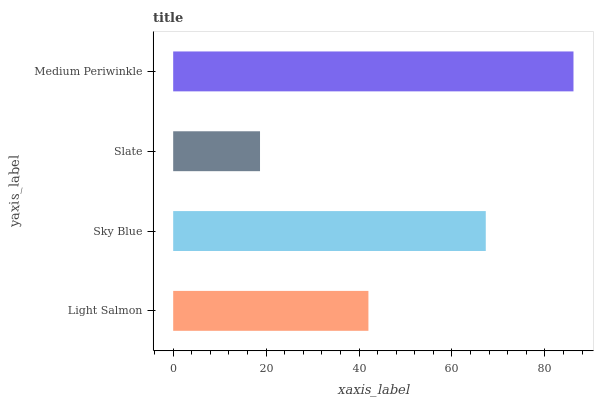Is Slate the minimum?
Answer yes or no. Yes. Is Medium Periwinkle the maximum?
Answer yes or no. Yes. Is Sky Blue the minimum?
Answer yes or no. No. Is Sky Blue the maximum?
Answer yes or no. No. Is Sky Blue greater than Light Salmon?
Answer yes or no. Yes. Is Light Salmon less than Sky Blue?
Answer yes or no. Yes. Is Light Salmon greater than Sky Blue?
Answer yes or no. No. Is Sky Blue less than Light Salmon?
Answer yes or no. No. Is Sky Blue the high median?
Answer yes or no. Yes. Is Light Salmon the low median?
Answer yes or no. Yes. Is Medium Periwinkle the high median?
Answer yes or no. No. Is Sky Blue the low median?
Answer yes or no. No. 